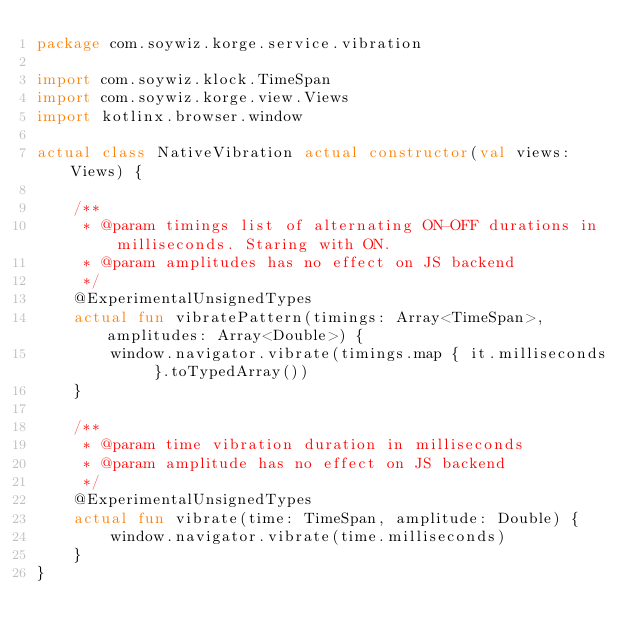<code> <loc_0><loc_0><loc_500><loc_500><_Kotlin_>package com.soywiz.korge.service.vibration

import com.soywiz.klock.TimeSpan
import com.soywiz.korge.view.Views
import kotlinx.browser.window

actual class NativeVibration actual constructor(val views: Views) {

    /**
     * @param timings list of alternating ON-OFF durations in milliseconds. Staring with ON.
     * @param amplitudes has no effect on JS backend
     */
    @ExperimentalUnsignedTypes
    actual fun vibratePattern(timings: Array<TimeSpan>, amplitudes: Array<Double>) {
        window.navigator.vibrate(timings.map { it.milliseconds }.toTypedArray())
    }

    /**
     * @param time vibration duration in milliseconds
     * @param amplitude has no effect on JS backend
     */
    @ExperimentalUnsignedTypes
    actual fun vibrate(time: TimeSpan, amplitude: Double) {
        window.navigator.vibrate(time.milliseconds)
    }
}
</code> 